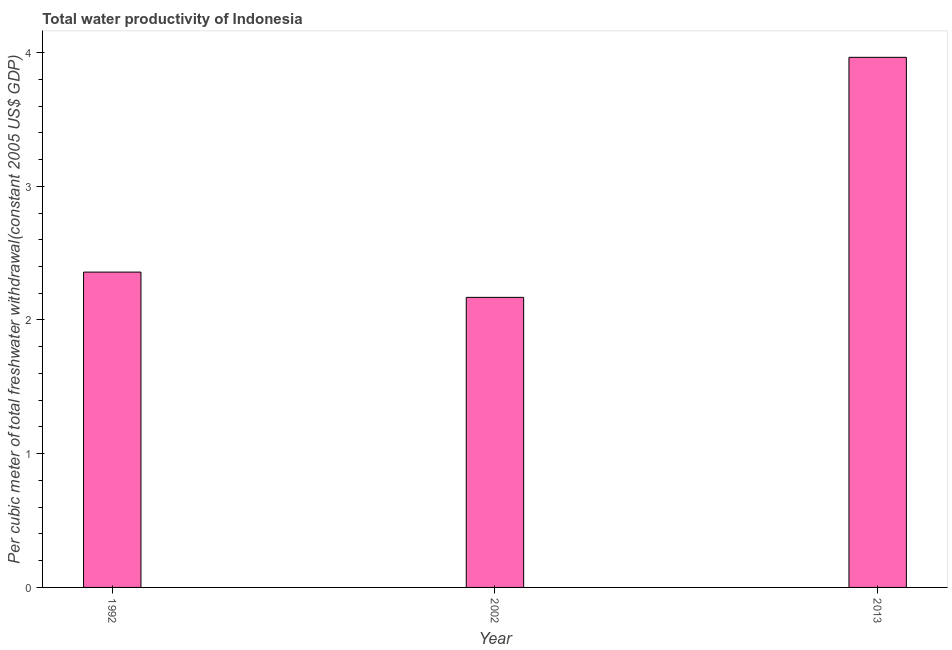Does the graph contain grids?
Offer a very short reply. No. What is the title of the graph?
Give a very brief answer. Total water productivity of Indonesia. What is the label or title of the Y-axis?
Your answer should be very brief. Per cubic meter of total freshwater withdrawal(constant 2005 US$ GDP). What is the total water productivity in 2002?
Offer a very short reply. 2.17. Across all years, what is the maximum total water productivity?
Keep it short and to the point. 3.96. Across all years, what is the minimum total water productivity?
Your answer should be compact. 2.17. In which year was the total water productivity maximum?
Make the answer very short. 2013. What is the sum of the total water productivity?
Offer a terse response. 8.49. What is the difference between the total water productivity in 2002 and 2013?
Provide a short and direct response. -1.79. What is the average total water productivity per year?
Your answer should be very brief. 2.83. What is the median total water productivity?
Ensure brevity in your answer.  2.36. What is the ratio of the total water productivity in 1992 to that in 2013?
Provide a short and direct response. 0.59. Is the total water productivity in 1992 less than that in 2013?
Your answer should be compact. Yes. Is the difference between the total water productivity in 1992 and 2013 greater than the difference between any two years?
Keep it short and to the point. No. What is the difference between the highest and the second highest total water productivity?
Provide a succinct answer. 1.61. Is the sum of the total water productivity in 1992 and 2013 greater than the maximum total water productivity across all years?
Provide a succinct answer. Yes. How many bars are there?
Ensure brevity in your answer.  3. How many years are there in the graph?
Keep it short and to the point. 3. What is the difference between two consecutive major ticks on the Y-axis?
Provide a succinct answer. 1. Are the values on the major ticks of Y-axis written in scientific E-notation?
Your answer should be compact. No. What is the Per cubic meter of total freshwater withdrawal(constant 2005 US$ GDP) of 1992?
Offer a terse response. 2.36. What is the Per cubic meter of total freshwater withdrawal(constant 2005 US$ GDP) in 2002?
Offer a terse response. 2.17. What is the Per cubic meter of total freshwater withdrawal(constant 2005 US$ GDP) in 2013?
Provide a succinct answer. 3.96. What is the difference between the Per cubic meter of total freshwater withdrawal(constant 2005 US$ GDP) in 1992 and 2002?
Your answer should be very brief. 0.19. What is the difference between the Per cubic meter of total freshwater withdrawal(constant 2005 US$ GDP) in 1992 and 2013?
Provide a short and direct response. -1.61. What is the difference between the Per cubic meter of total freshwater withdrawal(constant 2005 US$ GDP) in 2002 and 2013?
Offer a very short reply. -1.8. What is the ratio of the Per cubic meter of total freshwater withdrawal(constant 2005 US$ GDP) in 1992 to that in 2002?
Ensure brevity in your answer.  1.09. What is the ratio of the Per cubic meter of total freshwater withdrawal(constant 2005 US$ GDP) in 1992 to that in 2013?
Provide a succinct answer. 0.59. What is the ratio of the Per cubic meter of total freshwater withdrawal(constant 2005 US$ GDP) in 2002 to that in 2013?
Your response must be concise. 0.55. 